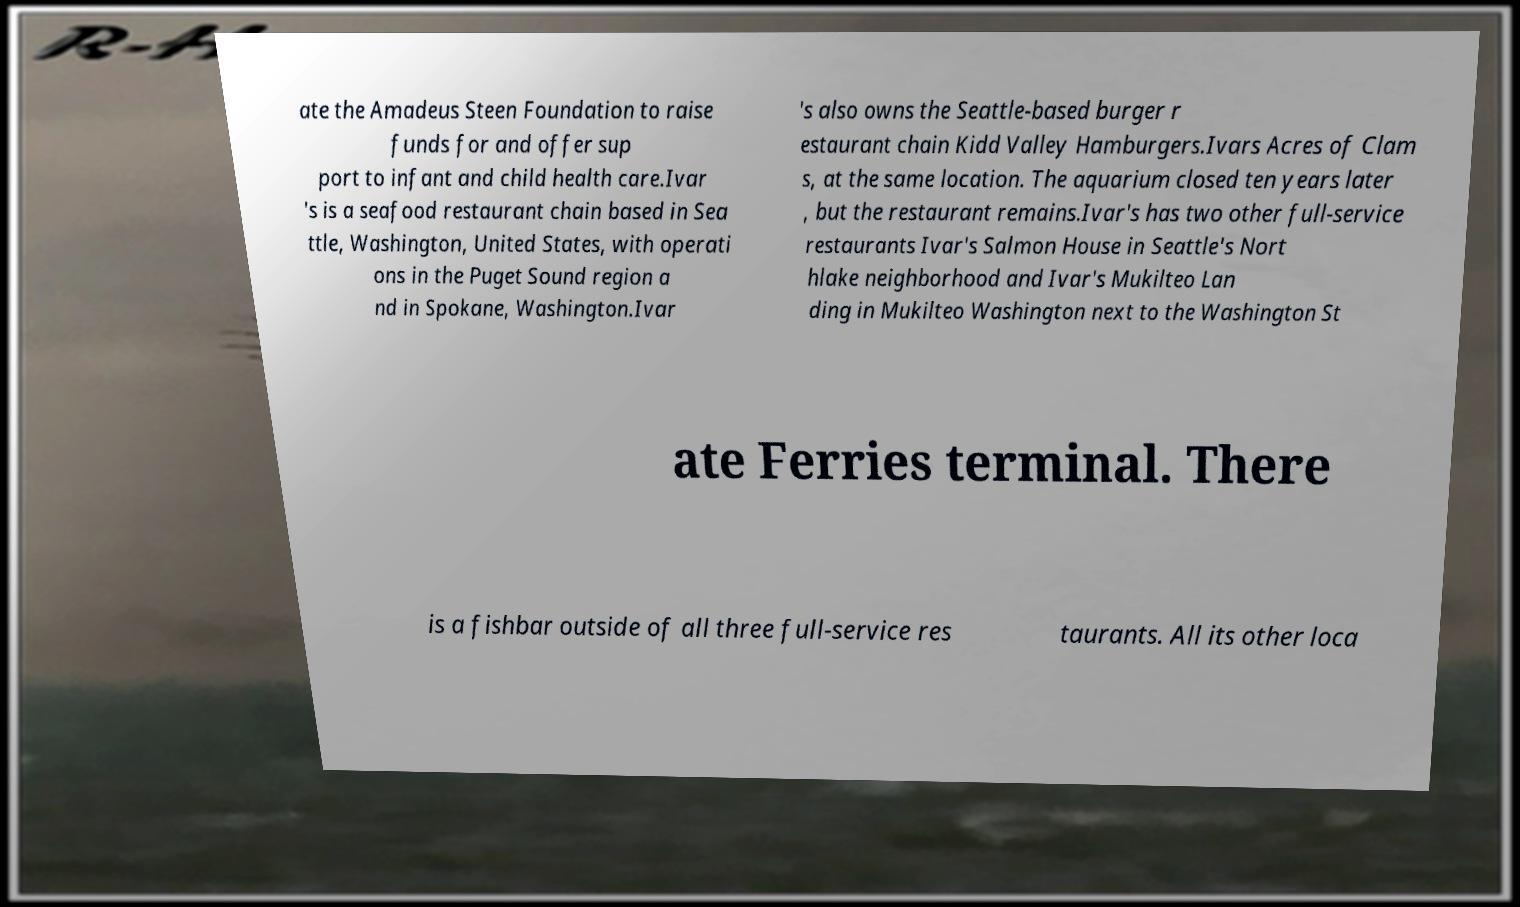There's text embedded in this image that I need extracted. Can you transcribe it verbatim? ate the Amadeus Steen Foundation to raise funds for and offer sup port to infant and child health care.Ivar 's is a seafood restaurant chain based in Sea ttle, Washington, United States, with operati ons in the Puget Sound region a nd in Spokane, Washington.Ivar 's also owns the Seattle-based burger r estaurant chain Kidd Valley Hamburgers.Ivars Acres of Clam s, at the same location. The aquarium closed ten years later , but the restaurant remains.Ivar's has two other full-service restaurants Ivar's Salmon House in Seattle's Nort hlake neighborhood and Ivar's Mukilteo Lan ding in Mukilteo Washington next to the Washington St ate Ferries terminal. There is a fishbar outside of all three full-service res taurants. All its other loca 